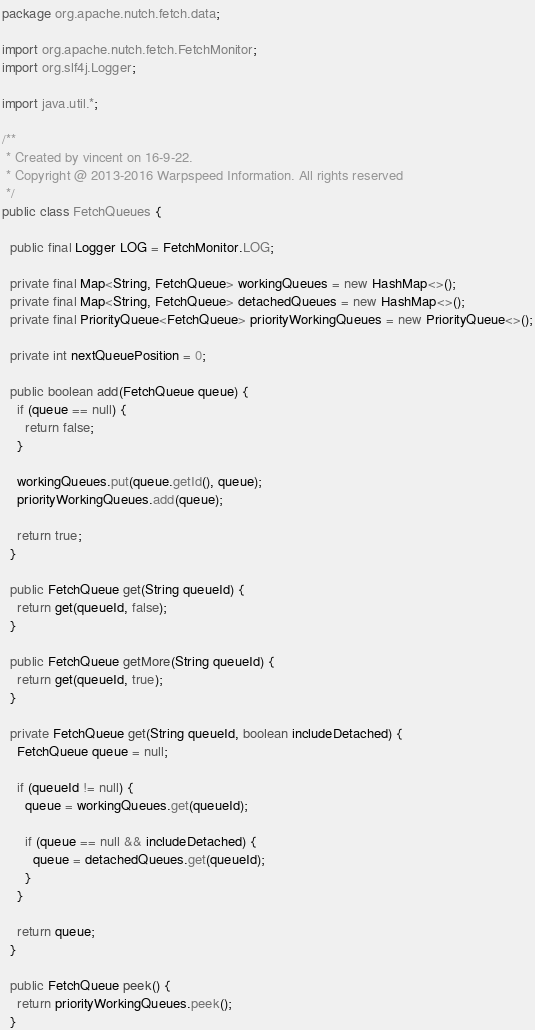<code> <loc_0><loc_0><loc_500><loc_500><_Java_>package org.apache.nutch.fetch.data;

import org.apache.nutch.fetch.FetchMonitor;
import org.slf4j.Logger;

import java.util.*;

/**
 * Created by vincent on 16-9-22.
 * Copyright @ 2013-2016 Warpspeed Information. All rights reserved
 */
public class FetchQueues {

  public final Logger LOG = FetchMonitor.LOG;

  private final Map<String, FetchQueue> workingQueues = new HashMap<>();
  private final Map<String, FetchQueue> detachedQueues = new HashMap<>();
  private final PriorityQueue<FetchQueue> priorityWorkingQueues = new PriorityQueue<>();

  private int nextQueuePosition = 0;

  public boolean add(FetchQueue queue) {
    if (queue == null) {
      return false;
    }

    workingQueues.put(queue.getId(), queue);
    priorityWorkingQueues.add(queue);

    return true;
  }

  public FetchQueue get(String queueId) {
    return get(queueId, false);
  }

  public FetchQueue getMore(String queueId) {
    return get(queueId, true);
  }

  private FetchQueue get(String queueId, boolean includeDetached) {
    FetchQueue queue = null;

    if (queueId != null) {
      queue = workingQueues.get(queueId);

      if (queue == null && includeDetached) {
        queue = detachedQueues.get(queueId);
      }
    }

    return queue;
  }

  public FetchQueue peek() {
    return priorityWorkingQueues.peek();
  }
</code> 